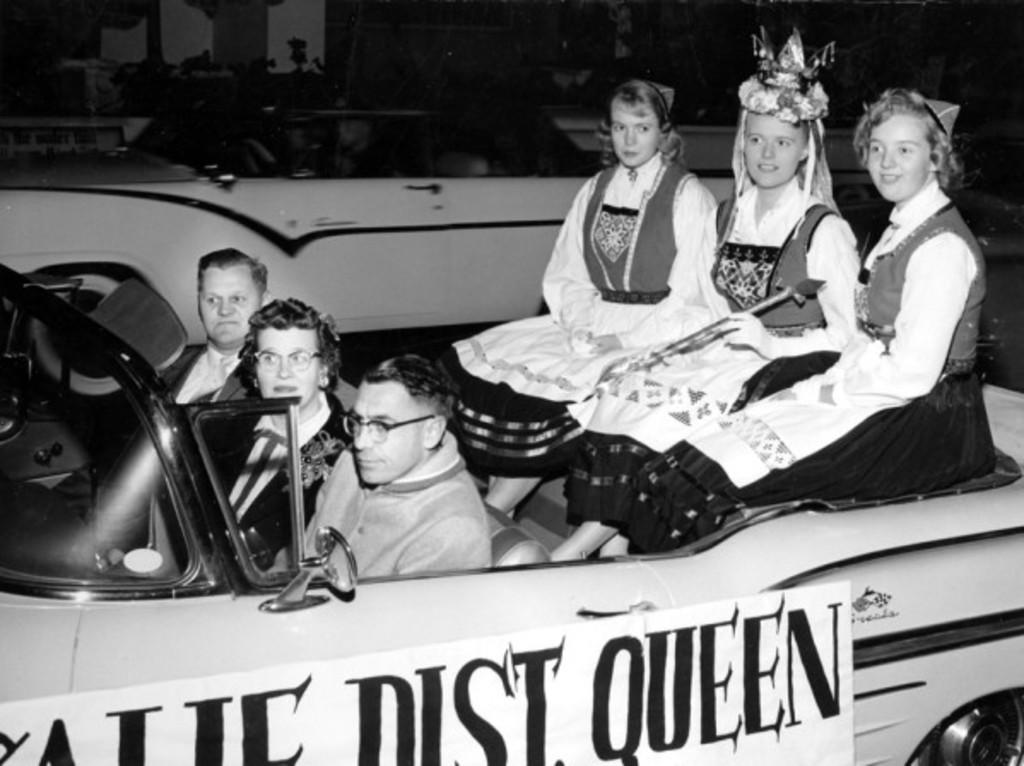How many people are in the image? There is a group of people in the image. What are the people doing in the image? The people are sitting on a car and riding it. What can be seen on the car in the image? There is a poster on the car, and it features the words "dust queen." What type of fruit is being used to fuel the car in the image? There is no fruit present in the image, and the car is not being fueled by any fruit. 